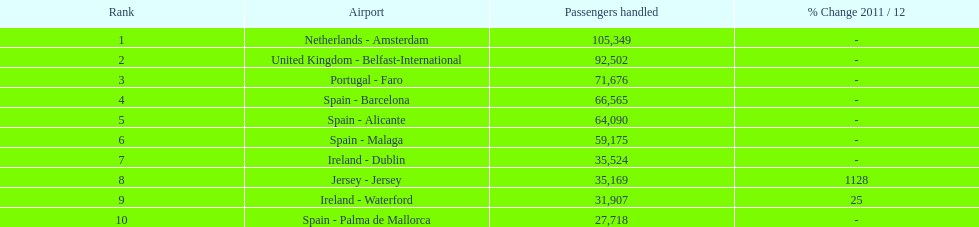How does the number of passengers handled differ between the best-ranked airport in the netherlands (amsterdam) and spain (palma de mallorca)? 77,631. 